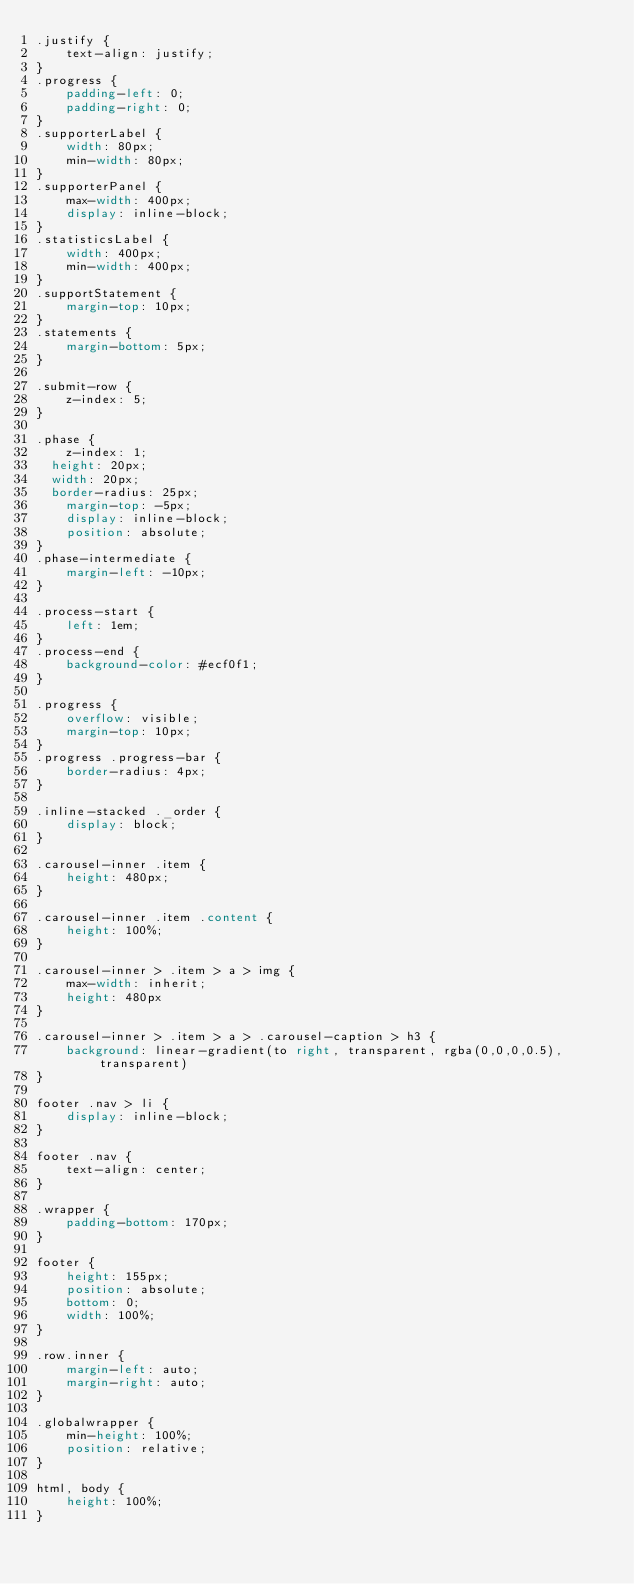Convert code to text. <code><loc_0><loc_0><loc_500><loc_500><_CSS_>.justify {
    text-align: justify;
}
.progress {
    padding-left: 0;
    padding-right: 0;
}
.supporterLabel {
    width: 80px;
    min-width: 80px;
}
.supporterPanel {
    max-width: 400px;
    display: inline-block;
}
.statisticsLabel {
    width: 400px;
    min-width: 400px;
}
.supportStatement {
    margin-top: 10px;
}
.statements {
    margin-bottom: 5px;
}

.submit-row {
    z-index: 5;
}

.phase {
    z-index: 1;
	height: 20px;
	width: 20px;
	border-radius: 25px;
    margin-top: -5px;
    display: inline-block;
    position: absolute;
}
.phase-intermediate {
    margin-left: -10px;
}

.process-start {
    left: 1em;
}
.process-end {
    background-color: #ecf0f1;
}

.progress {
    overflow: visible;
    margin-top: 10px;
}
.progress .progress-bar {
    border-radius: 4px;
}

.inline-stacked ._order {
    display: block;
}

.carousel-inner .item {
    height: 480px;
}

.carousel-inner .item .content {
    height: 100%;
}

.carousel-inner > .item > a > img {
    max-width: inherit;
    height: 480px
}

.carousel-inner > .item > a > .carousel-caption > h3 {
    background: linear-gradient(to right, transparent, rgba(0,0,0,0.5), transparent)
}

footer .nav > li {
    display: inline-block;
}

footer .nav {
    text-align: center;
}

.wrapper {
    padding-bottom: 170px;
}

footer {
    height: 155px;
    position: absolute;
    bottom: 0;
    width: 100%;
}

.row.inner {
    margin-left: auto;
    margin-right: auto;
}

.globalwrapper {
    min-height: 100%;
    position: relative;
}

html, body {
    height: 100%;
}
</code> 